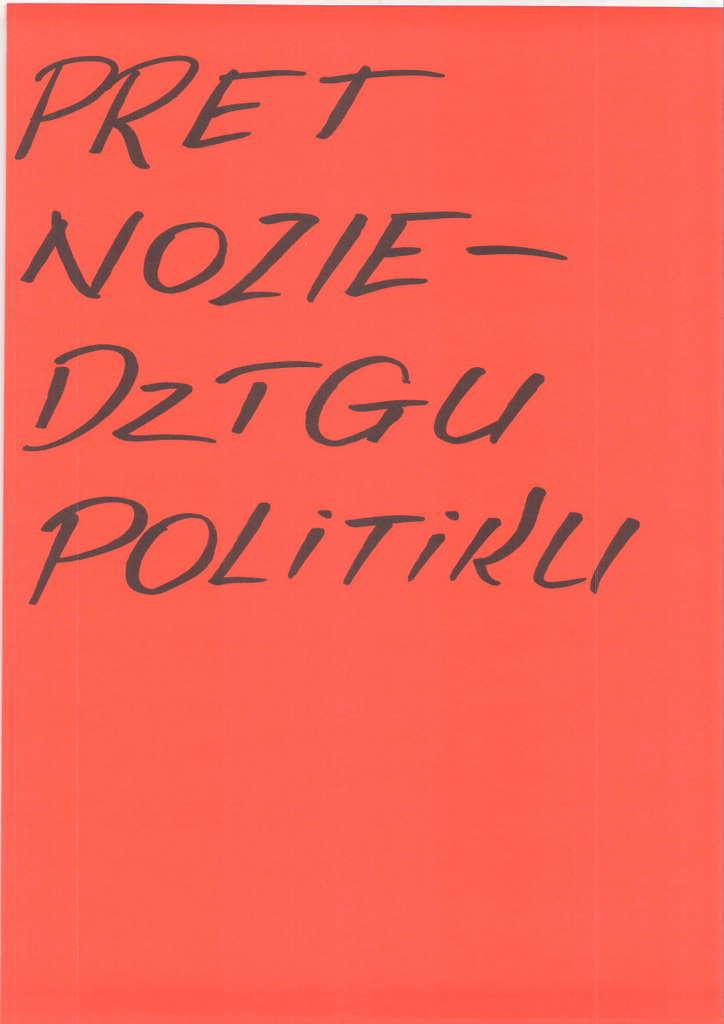What color is the background of the image? The background of the image is orange. What color is the text on the image? The text on the image is written in black color. How many noses can be seen in the image? There are no noses present in the image. What type of fruit is depicted in the image? There is no fruit depicted in the image. 